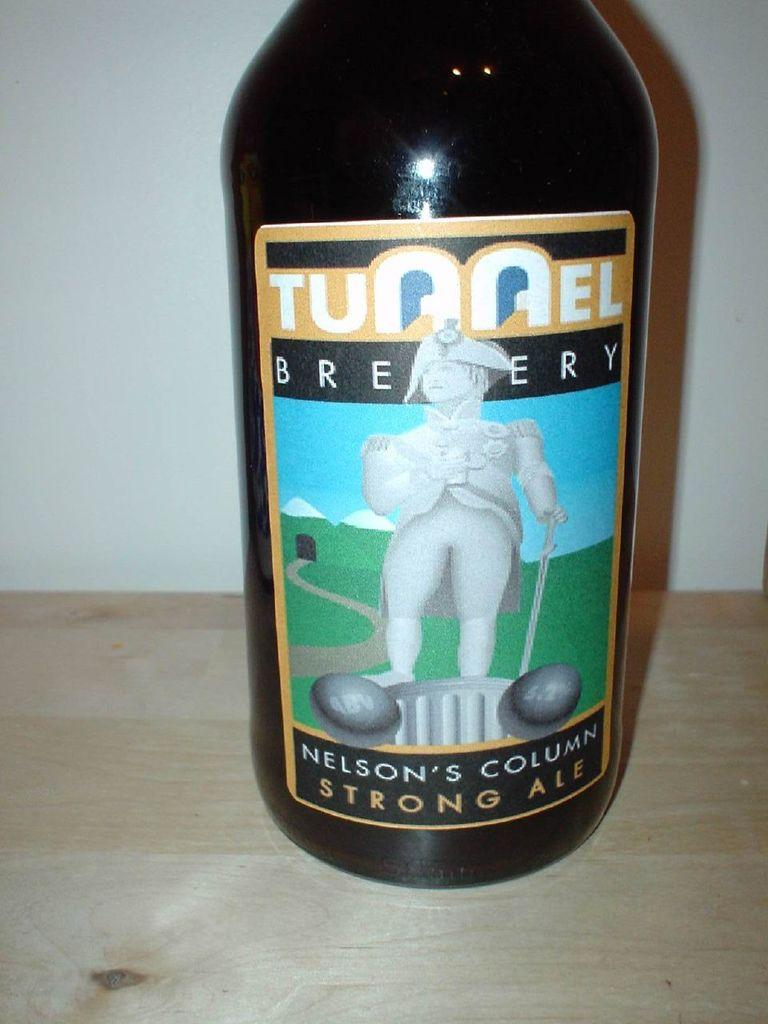<image>
Present a compact description of the photo's key features. Nelson's Column Strong Ale Beer with a label of a man. 